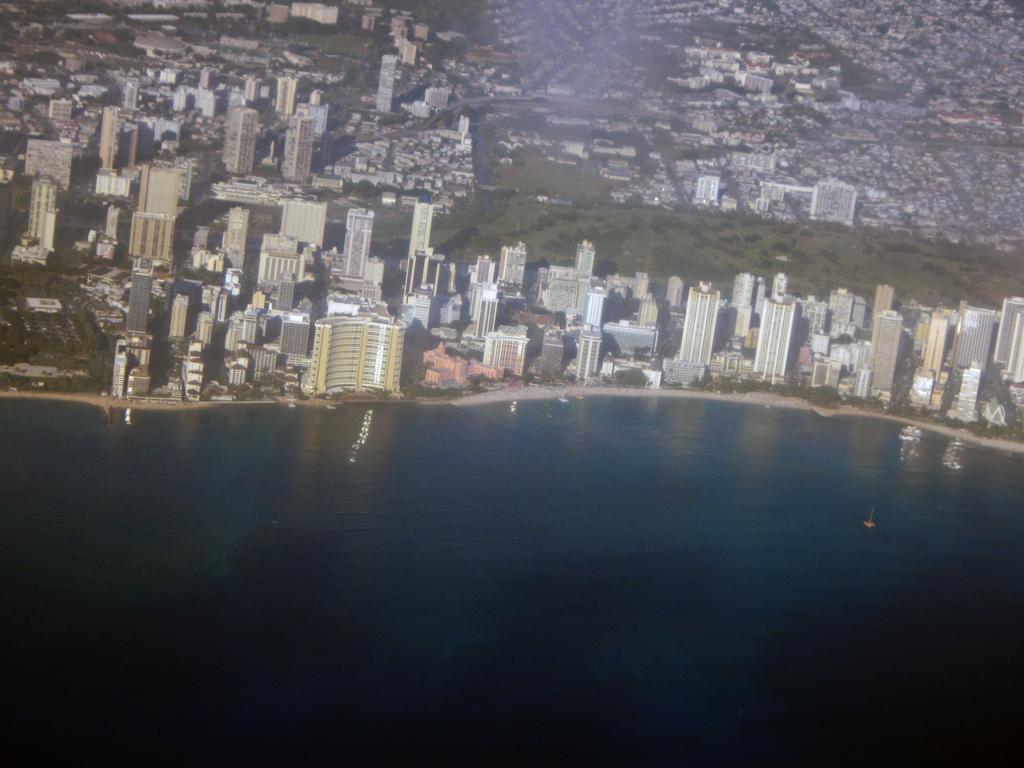Describe this image in one or two sentences. In this picture we can see buildings, water and trees. 